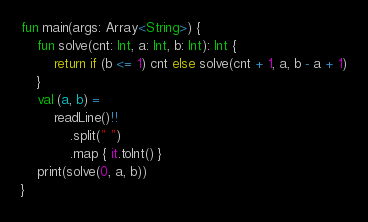Convert code to text. <code><loc_0><loc_0><loc_500><loc_500><_Kotlin_>fun main(args: Array<String>) {
    fun solve(cnt: Int, a: Int, b: Int): Int {
        return if (b <= 1) cnt else solve(cnt + 1, a, b - a + 1)
    }
    val (a, b) =
        readLine()!!
            .split(" ")
            .map { it.toInt() }
    print(solve(0, a, b))
}</code> 